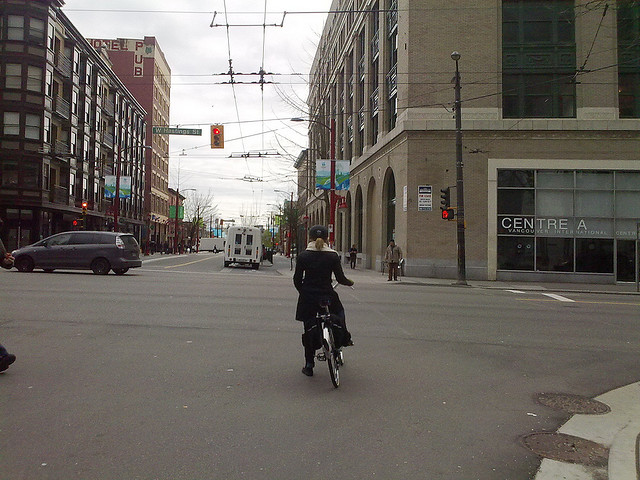What province is she riding in?
A. ontario
B. manitoba
C. alberta
D. british columbia
Answer with the option's letter from the given choices directly. She is riding in D. British Columbia. Considering the architecture and street details along with identifying cues like the visible signage, this location aligns with an urban area in British Columbia. 